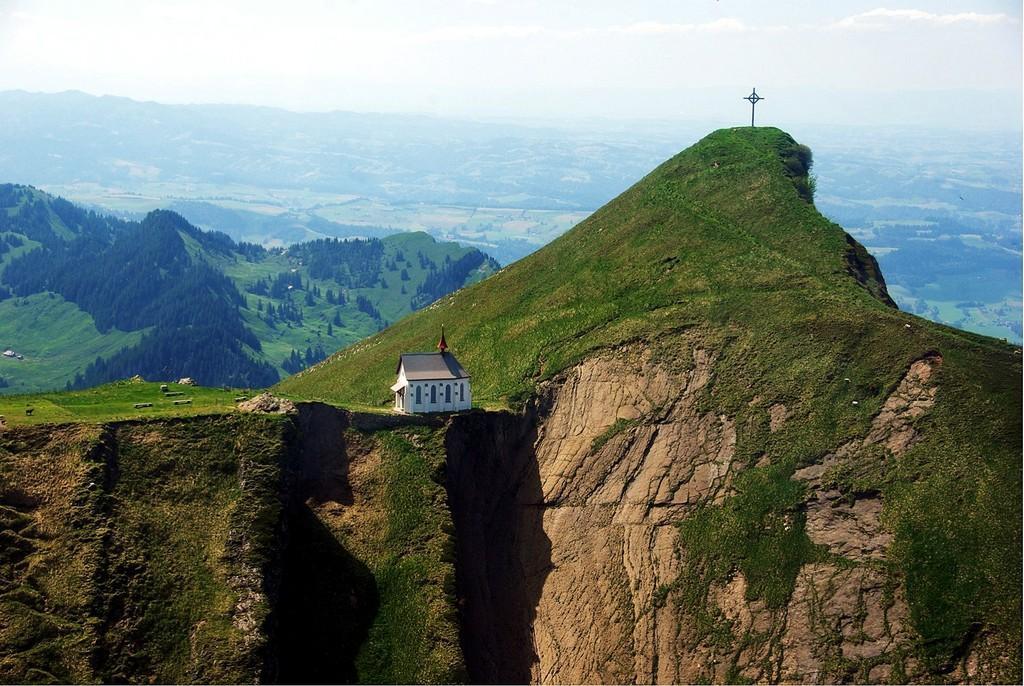Please provide a concise description of this image. In the image in the center we can see one house,wall and roof. In the background we can see sky,clouds,mountain,cross,trees,plants and grass. 